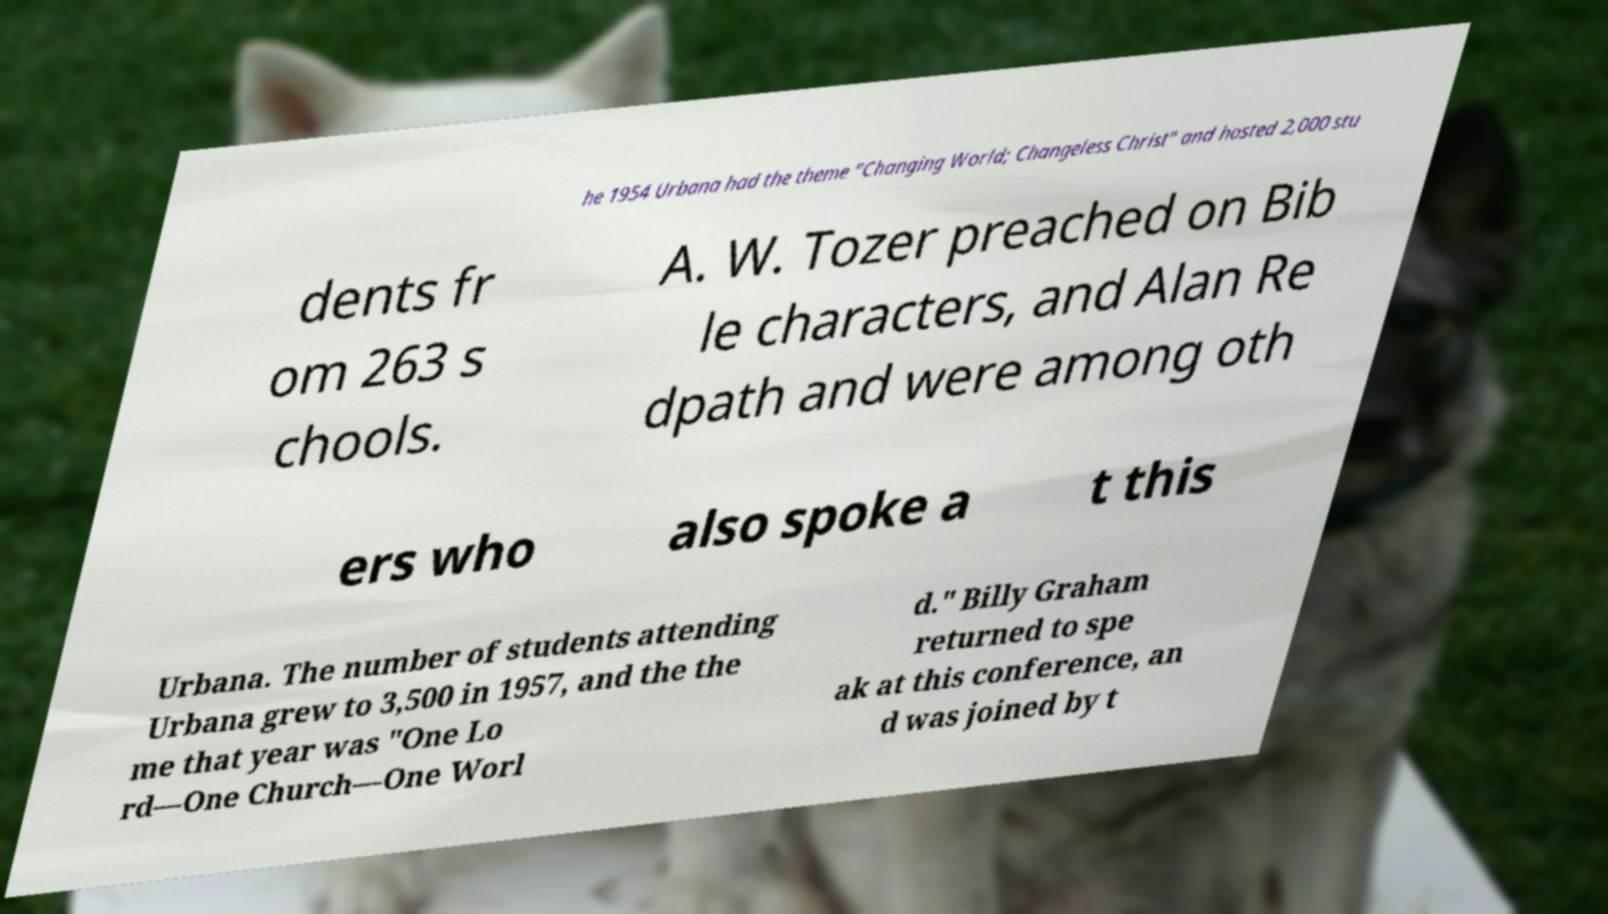Can you accurately transcribe the text from the provided image for me? he 1954 Urbana had the theme "Changing World; Changeless Christ" and hosted 2,000 stu dents fr om 263 s chools. A. W. Tozer preached on Bib le characters, and Alan Re dpath and were among oth ers who also spoke a t this Urbana. The number of students attending Urbana grew to 3,500 in 1957, and the the me that year was "One Lo rd—One Church—One Worl d." Billy Graham returned to spe ak at this conference, an d was joined by t 